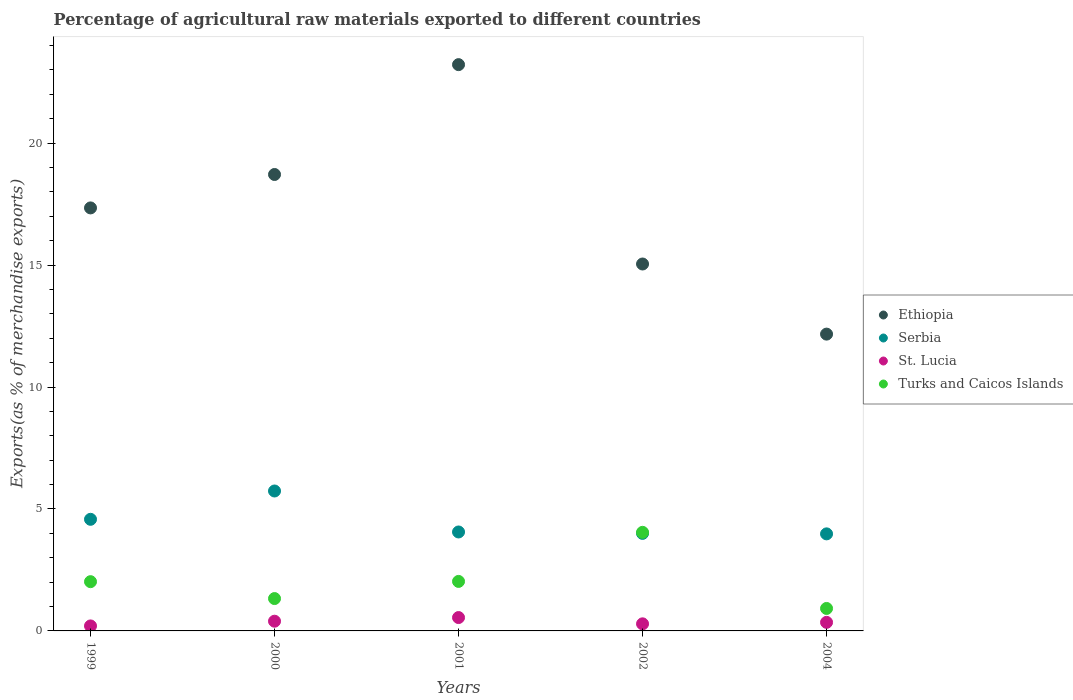Is the number of dotlines equal to the number of legend labels?
Your answer should be compact. Yes. What is the percentage of exports to different countries in Turks and Caicos Islands in 2002?
Provide a short and direct response. 4.04. Across all years, what is the maximum percentage of exports to different countries in St. Lucia?
Make the answer very short. 0.55. Across all years, what is the minimum percentage of exports to different countries in Turks and Caicos Islands?
Your answer should be compact. 0.92. In which year was the percentage of exports to different countries in Turks and Caicos Islands maximum?
Your answer should be very brief. 2002. What is the total percentage of exports to different countries in Serbia in the graph?
Your answer should be very brief. 22.35. What is the difference between the percentage of exports to different countries in St. Lucia in 2000 and that in 2002?
Offer a very short reply. 0.11. What is the difference between the percentage of exports to different countries in Turks and Caicos Islands in 2002 and the percentage of exports to different countries in Serbia in 1999?
Provide a short and direct response. -0.53. What is the average percentage of exports to different countries in Serbia per year?
Keep it short and to the point. 4.47. In the year 1999, what is the difference between the percentage of exports to different countries in Ethiopia and percentage of exports to different countries in Serbia?
Your answer should be compact. 12.77. What is the ratio of the percentage of exports to different countries in St. Lucia in 2001 to that in 2004?
Give a very brief answer. 1.56. Is the percentage of exports to different countries in Serbia in 2002 less than that in 2004?
Ensure brevity in your answer.  No. Is the difference between the percentage of exports to different countries in Ethiopia in 1999 and 2000 greater than the difference between the percentage of exports to different countries in Serbia in 1999 and 2000?
Your answer should be compact. No. What is the difference between the highest and the second highest percentage of exports to different countries in Turks and Caicos Islands?
Keep it short and to the point. 2.01. What is the difference between the highest and the lowest percentage of exports to different countries in Ethiopia?
Offer a very short reply. 11.05. Is the sum of the percentage of exports to different countries in Serbia in 2000 and 2002 greater than the maximum percentage of exports to different countries in Turks and Caicos Islands across all years?
Provide a short and direct response. Yes. Is it the case that in every year, the sum of the percentage of exports to different countries in Serbia and percentage of exports to different countries in Turks and Caicos Islands  is greater than the sum of percentage of exports to different countries in Ethiopia and percentage of exports to different countries in St. Lucia?
Keep it short and to the point. No. Is it the case that in every year, the sum of the percentage of exports to different countries in Serbia and percentage of exports to different countries in Ethiopia  is greater than the percentage of exports to different countries in Turks and Caicos Islands?
Ensure brevity in your answer.  Yes. Is the percentage of exports to different countries in Turks and Caicos Islands strictly greater than the percentage of exports to different countries in Ethiopia over the years?
Give a very brief answer. No. Is the percentage of exports to different countries in St. Lucia strictly less than the percentage of exports to different countries in Ethiopia over the years?
Your answer should be very brief. Yes. How many dotlines are there?
Ensure brevity in your answer.  4. How many years are there in the graph?
Give a very brief answer. 5. Are the values on the major ticks of Y-axis written in scientific E-notation?
Give a very brief answer. No. Does the graph contain grids?
Offer a very short reply. No. Where does the legend appear in the graph?
Give a very brief answer. Center right. How are the legend labels stacked?
Your answer should be compact. Vertical. What is the title of the graph?
Provide a succinct answer. Percentage of agricultural raw materials exported to different countries. Does "Dominican Republic" appear as one of the legend labels in the graph?
Your answer should be compact. No. What is the label or title of the Y-axis?
Your answer should be very brief. Exports(as % of merchandise exports). What is the Exports(as % of merchandise exports) in Ethiopia in 1999?
Keep it short and to the point. 17.34. What is the Exports(as % of merchandise exports) in Serbia in 1999?
Your answer should be very brief. 4.58. What is the Exports(as % of merchandise exports) of St. Lucia in 1999?
Make the answer very short. 0.2. What is the Exports(as % of merchandise exports) in Turks and Caicos Islands in 1999?
Your answer should be compact. 2.02. What is the Exports(as % of merchandise exports) of Ethiopia in 2000?
Your answer should be very brief. 18.71. What is the Exports(as % of merchandise exports) of Serbia in 2000?
Keep it short and to the point. 5.74. What is the Exports(as % of merchandise exports) in St. Lucia in 2000?
Your response must be concise. 0.4. What is the Exports(as % of merchandise exports) in Turks and Caicos Islands in 2000?
Provide a succinct answer. 1.33. What is the Exports(as % of merchandise exports) in Ethiopia in 2001?
Offer a very short reply. 23.22. What is the Exports(as % of merchandise exports) in Serbia in 2001?
Provide a short and direct response. 4.06. What is the Exports(as % of merchandise exports) of St. Lucia in 2001?
Your answer should be very brief. 0.55. What is the Exports(as % of merchandise exports) in Turks and Caicos Islands in 2001?
Make the answer very short. 2.03. What is the Exports(as % of merchandise exports) of Ethiopia in 2002?
Offer a terse response. 15.04. What is the Exports(as % of merchandise exports) of Serbia in 2002?
Give a very brief answer. 4. What is the Exports(as % of merchandise exports) of St. Lucia in 2002?
Give a very brief answer. 0.29. What is the Exports(as % of merchandise exports) of Turks and Caicos Islands in 2002?
Offer a terse response. 4.04. What is the Exports(as % of merchandise exports) in Ethiopia in 2004?
Give a very brief answer. 12.17. What is the Exports(as % of merchandise exports) in Serbia in 2004?
Your response must be concise. 3.98. What is the Exports(as % of merchandise exports) in St. Lucia in 2004?
Provide a succinct answer. 0.35. What is the Exports(as % of merchandise exports) in Turks and Caicos Islands in 2004?
Your response must be concise. 0.92. Across all years, what is the maximum Exports(as % of merchandise exports) in Ethiopia?
Keep it short and to the point. 23.22. Across all years, what is the maximum Exports(as % of merchandise exports) of Serbia?
Make the answer very short. 5.74. Across all years, what is the maximum Exports(as % of merchandise exports) of St. Lucia?
Provide a short and direct response. 0.55. Across all years, what is the maximum Exports(as % of merchandise exports) in Turks and Caicos Islands?
Ensure brevity in your answer.  4.04. Across all years, what is the minimum Exports(as % of merchandise exports) in Ethiopia?
Give a very brief answer. 12.17. Across all years, what is the minimum Exports(as % of merchandise exports) of Serbia?
Offer a very short reply. 3.98. Across all years, what is the minimum Exports(as % of merchandise exports) of St. Lucia?
Provide a short and direct response. 0.2. Across all years, what is the minimum Exports(as % of merchandise exports) of Turks and Caicos Islands?
Offer a very short reply. 0.92. What is the total Exports(as % of merchandise exports) in Ethiopia in the graph?
Provide a succinct answer. 86.49. What is the total Exports(as % of merchandise exports) in Serbia in the graph?
Your answer should be very brief. 22.35. What is the total Exports(as % of merchandise exports) of St. Lucia in the graph?
Your answer should be compact. 1.79. What is the total Exports(as % of merchandise exports) in Turks and Caicos Islands in the graph?
Offer a very short reply. 10.34. What is the difference between the Exports(as % of merchandise exports) in Ethiopia in 1999 and that in 2000?
Give a very brief answer. -1.37. What is the difference between the Exports(as % of merchandise exports) in Serbia in 1999 and that in 2000?
Offer a very short reply. -1.16. What is the difference between the Exports(as % of merchandise exports) of St. Lucia in 1999 and that in 2000?
Provide a succinct answer. -0.19. What is the difference between the Exports(as % of merchandise exports) in Turks and Caicos Islands in 1999 and that in 2000?
Ensure brevity in your answer.  0.69. What is the difference between the Exports(as % of merchandise exports) in Ethiopia in 1999 and that in 2001?
Ensure brevity in your answer.  -5.87. What is the difference between the Exports(as % of merchandise exports) in Serbia in 1999 and that in 2001?
Provide a succinct answer. 0.52. What is the difference between the Exports(as % of merchandise exports) in St. Lucia in 1999 and that in 2001?
Your response must be concise. -0.34. What is the difference between the Exports(as % of merchandise exports) of Turks and Caicos Islands in 1999 and that in 2001?
Provide a short and direct response. -0.01. What is the difference between the Exports(as % of merchandise exports) in Ethiopia in 1999 and that in 2002?
Your response must be concise. 2.3. What is the difference between the Exports(as % of merchandise exports) of Serbia in 1999 and that in 2002?
Keep it short and to the point. 0.58. What is the difference between the Exports(as % of merchandise exports) of St. Lucia in 1999 and that in 2002?
Ensure brevity in your answer.  -0.09. What is the difference between the Exports(as % of merchandise exports) in Turks and Caicos Islands in 1999 and that in 2002?
Make the answer very short. -2.02. What is the difference between the Exports(as % of merchandise exports) in Ethiopia in 1999 and that in 2004?
Keep it short and to the point. 5.17. What is the difference between the Exports(as % of merchandise exports) of Serbia in 1999 and that in 2004?
Give a very brief answer. 0.6. What is the difference between the Exports(as % of merchandise exports) of St. Lucia in 1999 and that in 2004?
Your response must be concise. -0.15. What is the difference between the Exports(as % of merchandise exports) in Turks and Caicos Islands in 1999 and that in 2004?
Provide a succinct answer. 1.1. What is the difference between the Exports(as % of merchandise exports) of Ethiopia in 2000 and that in 2001?
Provide a succinct answer. -4.5. What is the difference between the Exports(as % of merchandise exports) in Serbia in 2000 and that in 2001?
Give a very brief answer. 1.68. What is the difference between the Exports(as % of merchandise exports) of St. Lucia in 2000 and that in 2001?
Provide a succinct answer. -0.15. What is the difference between the Exports(as % of merchandise exports) in Turks and Caicos Islands in 2000 and that in 2001?
Offer a very short reply. -0.7. What is the difference between the Exports(as % of merchandise exports) in Ethiopia in 2000 and that in 2002?
Your answer should be compact. 3.67. What is the difference between the Exports(as % of merchandise exports) of Serbia in 2000 and that in 2002?
Offer a very short reply. 1.74. What is the difference between the Exports(as % of merchandise exports) of St. Lucia in 2000 and that in 2002?
Make the answer very short. 0.11. What is the difference between the Exports(as % of merchandise exports) in Turks and Caicos Islands in 2000 and that in 2002?
Offer a very short reply. -2.72. What is the difference between the Exports(as % of merchandise exports) in Ethiopia in 2000 and that in 2004?
Make the answer very short. 6.55. What is the difference between the Exports(as % of merchandise exports) of Serbia in 2000 and that in 2004?
Provide a short and direct response. 1.76. What is the difference between the Exports(as % of merchandise exports) of St. Lucia in 2000 and that in 2004?
Make the answer very short. 0.05. What is the difference between the Exports(as % of merchandise exports) of Turks and Caicos Islands in 2000 and that in 2004?
Make the answer very short. 0.41. What is the difference between the Exports(as % of merchandise exports) of Ethiopia in 2001 and that in 2002?
Your answer should be compact. 8.17. What is the difference between the Exports(as % of merchandise exports) of Serbia in 2001 and that in 2002?
Offer a terse response. 0.06. What is the difference between the Exports(as % of merchandise exports) of St. Lucia in 2001 and that in 2002?
Provide a short and direct response. 0.26. What is the difference between the Exports(as % of merchandise exports) in Turks and Caicos Islands in 2001 and that in 2002?
Make the answer very short. -2.01. What is the difference between the Exports(as % of merchandise exports) of Ethiopia in 2001 and that in 2004?
Offer a terse response. 11.05. What is the difference between the Exports(as % of merchandise exports) of Serbia in 2001 and that in 2004?
Ensure brevity in your answer.  0.08. What is the difference between the Exports(as % of merchandise exports) of St. Lucia in 2001 and that in 2004?
Make the answer very short. 0.2. What is the difference between the Exports(as % of merchandise exports) in Turks and Caicos Islands in 2001 and that in 2004?
Your answer should be compact. 1.11. What is the difference between the Exports(as % of merchandise exports) of Ethiopia in 2002 and that in 2004?
Offer a terse response. 2.88. What is the difference between the Exports(as % of merchandise exports) of Serbia in 2002 and that in 2004?
Your response must be concise. 0.02. What is the difference between the Exports(as % of merchandise exports) of St. Lucia in 2002 and that in 2004?
Provide a succinct answer. -0.06. What is the difference between the Exports(as % of merchandise exports) in Turks and Caicos Islands in 2002 and that in 2004?
Make the answer very short. 3.12. What is the difference between the Exports(as % of merchandise exports) in Ethiopia in 1999 and the Exports(as % of merchandise exports) in Serbia in 2000?
Provide a succinct answer. 11.61. What is the difference between the Exports(as % of merchandise exports) in Ethiopia in 1999 and the Exports(as % of merchandise exports) in St. Lucia in 2000?
Make the answer very short. 16.95. What is the difference between the Exports(as % of merchandise exports) of Ethiopia in 1999 and the Exports(as % of merchandise exports) of Turks and Caicos Islands in 2000?
Your answer should be very brief. 16.02. What is the difference between the Exports(as % of merchandise exports) in Serbia in 1999 and the Exports(as % of merchandise exports) in St. Lucia in 2000?
Keep it short and to the point. 4.18. What is the difference between the Exports(as % of merchandise exports) in Serbia in 1999 and the Exports(as % of merchandise exports) in Turks and Caicos Islands in 2000?
Make the answer very short. 3.25. What is the difference between the Exports(as % of merchandise exports) in St. Lucia in 1999 and the Exports(as % of merchandise exports) in Turks and Caicos Islands in 2000?
Your answer should be compact. -1.12. What is the difference between the Exports(as % of merchandise exports) in Ethiopia in 1999 and the Exports(as % of merchandise exports) in Serbia in 2001?
Give a very brief answer. 13.29. What is the difference between the Exports(as % of merchandise exports) of Ethiopia in 1999 and the Exports(as % of merchandise exports) of St. Lucia in 2001?
Make the answer very short. 16.8. What is the difference between the Exports(as % of merchandise exports) in Ethiopia in 1999 and the Exports(as % of merchandise exports) in Turks and Caicos Islands in 2001?
Offer a terse response. 15.31. What is the difference between the Exports(as % of merchandise exports) in Serbia in 1999 and the Exports(as % of merchandise exports) in St. Lucia in 2001?
Your answer should be compact. 4.03. What is the difference between the Exports(as % of merchandise exports) in Serbia in 1999 and the Exports(as % of merchandise exports) in Turks and Caicos Islands in 2001?
Provide a succinct answer. 2.55. What is the difference between the Exports(as % of merchandise exports) in St. Lucia in 1999 and the Exports(as % of merchandise exports) in Turks and Caicos Islands in 2001?
Keep it short and to the point. -1.83. What is the difference between the Exports(as % of merchandise exports) of Ethiopia in 1999 and the Exports(as % of merchandise exports) of Serbia in 2002?
Offer a terse response. 13.34. What is the difference between the Exports(as % of merchandise exports) of Ethiopia in 1999 and the Exports(as % of merchandise exports) of St. Lucia in 2002?
Offer a very short reply. 17.05. What is the difference between the Exports(as % of merchandise exports) in Ethiopia in 1999 and the Exports(as % of merchandise exports) in Turks and Caicos Islands in 2002?
Your answer should be compact. 13.3. What is the difference between the Exports(as % of merchandise exports) in Serbia in 1999 and the Exports(as % of merchandise exports) in St. Lucia in 2002?
Give a very brief answer. 4.29. What is the difference between the Exports(as % of merchandise exports) of Serbia in 1999 and the Exports(as % of merchandise exports) of Turks and Caicos Islands in 2002?
Ensure brevity in your answer.  0.53. What is the difference between the Exports(as % of merchandise exports) of St. Lucia in 1999 and the Exports(as % of merchandise exports) of Turks and Caicos Islands in 2002?
Offer a very short reply. -3.84. What is the difference between the Exports(as % of merchandise exports) in Ethiopia in 1999 and the Exports(as % of merchandise exports) in Serbia in 2004?
Make the answer very short. 13.37. What is the difference between the Exports(as % of merchandise exports) of Ethiopia in 1999 and the Exports(as % of merchandise exports) of St. Lucia in 2004?
Keep it short and to the point. 16.99. What is the difference between the Exports(as % of merchandise exports) of Ethiopia in 1999 and the Exports(as % of merchandise exports) of Turks and Caicos Islands in 2004?
Provide a short and direct response. 16.42. What is the difference between the Exports(as % of merchandise exports) of Serbia in 1999 and the Exports(as % of merchandise exports) of St. Lucia in 2004?
Offer a very short reply. 4.23. What is the difference between the Exports(as % of merchandise exports) in Serbia in 1999 and the Exports(as % of merchandise exports) in Turks and Caicos Islands in 2004?
Provide a short and direct response. 3.66. What is the difference between the Exports(as % of merchandise exports) in St. Lucia in 1999 and the Exports(as % of merchandise exports) in Turks and Caicos Islands in 2004?
Keep it short and to the point. -0.72. What is the difference between the Exports(as % of merchandise exports) of Ethiopia in 2000 and the Exports(as % of merchandise exports) of Serbia in 2001?
Your answer should be compact. 14.66. What is the difference between the Exports(as % of merchandise exports) of Ethiopia in 2000 and the Exports(as % of merchandise exports) of St. Lucia in 2001?
Ensure brevity in your answer.  18.17. What is the difference between the Exports(as % of merchandise exports) in Ethiopia in 2000 and the Exports(as % of merchandise exports) in Turks and Caicos Islands in 2001?
Your response must be concise. 16.68. What is the difference between the Exports(as % of merchandise exports) of Serbia in 2000 and the Exports(as % of merchandise exports) of St. Lucia in 2001?
Your response must be concise. 5.19. What is the difference between the Exports(as % of merchandise exports) of Serbia in 2000 and the Exports(as % of merchandise exports) of Turks and Caicos Islands in 2001?
Give a very brief answer. 3.71. What is the difference between the Exports(as % of merchandise exports) in St. Lucia in 2000 and the Exports(as % of merchandise exports) in Turks and Caicos Islands in 2001?
Offer a very short reply. -1.63. What is the difference between the Exports(as % of merchandise exports) of Ethiopia in 2000 and the Exports(as % of merchandise exports) of Serbia in 2002?
Provide a short and direct response. 14.71. What is the difference between the Exports(as % of merchandise exports) of Ethiopia in 2000 and the Exports(as % of merchandise exports) of St. Lucia in 2002?
Make the answer very short. 18.42. What is the difference between the Exports(as % of merchandise exports) of Ethiopia in 2000 and the Exports(as % of merchandise exports) of Turks and Caicos Islands in 2002?
Provide a succinct answer. 14.67. What is the difference between the Exports(as % of merchandise exports) in Serbia in 2000 and the Exports(as % of merchandise exports) in St. Lucia in 2002?
Your response must be concise. 5.45. What is the difference between the Exports(as % of merchandise exports) of Serbia in 2000 and the Exports(as % of merchandise exports) of Turks and Caicos Islands in 2002?
Keep it short and to the point. 1.7. What is the difference between the Exports(as % of merchandise exports) of St. Lucia in 2000 and the Exports(as % of merchandise exports) of Turks and Caicos Islands in 2002?
Make the answer very short. -3.64. What is the difference between the Exports(as % of merchandise exports) of Ethiopia in 2000 and the Exports(as % of merchandise exports) of Serbia in 2004?
Provide a short and direct response. 14.74. What is the difference between the Exports(as % of merchandise exports) of Ethiopia in 2000 and the Exports(as % of merchandise exports) of St. Lucia in 2004?
Ensure brevity in your answer.  18.36. What is the difference between the Exports(as % of merchandise exports) in Ethiopia in 2000 and the Exports(as % of merchandise exports) in Turks and Caicos Islands in 2004?
Offer a very short reply. 17.79. What is the difference between the Exports(as % of merchandise exports) of Serbia in 2000 and the Exports(as % of merchandise exports) of St. Lucia in 2004?
Offer a terse response. 5.39. What is the difference between the Exports(as % of merchandise exports) of Serbia in 2000 and the Exports(as % of merchandise exports) of Turks and Caicos Islands in 2004?
Provide a short and direct response. 4.82. What is the difference between the Exports(as % of merchandise exports) of St. Lucia in 2000 and the Exports(as % of merchandise exports) of Turks and Caicos Islands in 2004?
Provide a short and direct response. -0.52. What is the difference between the Exports(as % of merchandise exports) of Ethiopia in 2001 and the Exports(as % of merchandise exports) of Serbia in 2002?
Your answer should be compact. 19.22. What is the difference between the Exports(as % of merchandise exports) of Ethiopia in 2001 and the Exports(as % of merchandise exports) of St. Lucia in 2002?
Offer a very short reply. 22.93. What is the difference between the Exports(as % of merchandise exports) of Ethiopia in 2001 and the Exports(as % of merchandise exports) of Turks and Caicos Islands in 2002?
Ensure brevity in your answer.  19.18. What is the difference between the Exports(as % of merchandise exports) of Serbia in 2001 and the Exports(as % of merchandise exports) of St. Lucia in 2002?
Offer a very short reply. 3.77. What is the difference between the Exports(as % of merchandise exports) in Serbia in 2001 and the Exports(as % of merchandise exports) in Turks and Caicos Islands in 2002?
Keep it short and to the point. 0.02. What is the difference between the Exports(as % of merchandise exports) of St. Lucia in 2001 and the Exports(as % of merchandise exports) of Turks and Caicos Islands in 2002?
Make the answer very short. -3.49. What is the difference between the Exports(as % of merchandise exports) in Ethiopia in 2001 and the Exports(as % of merchandise exports) in Serbia in 2004?
Provide a succinct answer. 19.24. What is the difference between the Exports(as % of merchandise exports) in Ethiopia in 2001 and the Exports(as % of merchandise exports) in St. Lucia in 2004?
Ensure brevity in your answer.  22.87. What is the difference between the Exports(as % of merchandise exports) of Ethiopia in 2001 and the Exports(as % of merchandise exports) of Turks and Caicos Islands in 2004?
Ensure brevity in your answer.  22.3. What is the difference between the Exports(as % of merchandise exports) of Serbia in 2001 and the Exports(as % of merchandise exports) of St. Lucia in 2004?
Keep it short and to the point. 3.71. What is the difference between the Exports(as % of merchandise exports) of Serbia in 2001 and the Exports(as % of merchandise exports) of Turks and Caicos Islands in 2004?
Keep it short and to the point. 3.14. What is the difference between the Exports(as % of merchandise exports) in St. Lucia in 2001 and the Exports(as % of merchandise exports) in Turks and Caicos Islands in 2004?
Your answer should be compact. -0.37. What is the difference between the Exports(as % of merchandise exports) in Ethiopia in 2002 and the Exports(as % of merchandise exports) in Serbia in 2004?
Make the answer very short. 11.07. What is the difference between the Exports(as % of merchandise exports) in Ethiopia in 2002 and the Exports(as % of merchandise exports) in St. Lucia in 2004?
Keep it short and to the point. 14.69. What is the difference between the Exports(as % of merchandise exports) in Ethiopia in 2002 and the Exports(as % of merchandise exports) in Turks and Caicos Islands in 2004?
Ensure brevity in your answer.  14.12. What is the difference between the Exports(as % of merchandise exports) of Serbia in 2002 and the Exports(as % of merchandise exports) of St. Lucia in 2004?
Provide a short and direct response. 3.65. What is the difference between the Exports(as % of merchandise exports) in Serbia in 2002 and the Exports(as % of merchandise exports) in Turks and Caicos Islands in 2004?
Give a very brief answer. 3.08. What is the difference between the Exports(as % of merchandise exports) of St. Lucia in 2002 and the Exports(as % of merchandise exports) of Turks and Caicos Islands in 2004?
Provide a succinct answer. -0.63. What is the average Exports(as % of merchandise exports) in Ethiopia per year?
Your response must be concise. 17.3. What is the average Exports(as % of merchandise exports) of Serbia per year?
Give a very brief answer. 4.47. What is the average Exports(as % of merchandise exports) of St. Lucia per year?
Provide a succinct answer. 0.36. What is the average Exports(as % of merchandise exports) of Turks and Caicos Islands per year?
Make the answer very short. 2.07. In the year 1999, what is the difference between the Exports(as % of merchandise exports) in Ethiopia and Exports(as % of merchandise exports) in Serbia?
Give a very brief answer. 12.77. In the year 1999, what is the difference between the Exports(as % of merchandise exports) of Ethiopia and Exports(as % of merchandise exports) of St. Lucia?
Offer a very short reply. 17.14. In the year 1999, what is the difference between the Exports(as % of merchandise exports) of Ethiopia and Exports(as % of merchandise exports) of Turks and Caicos Islands?
Your answer should be compact. 15.33. In the year 1999, what is the difference between the Exports(as % of merchandise exports) in Serbia and Exports(as % of merchandise exports) in St. Lucia?
Offer a very short reply. 4.37. In the year 1999, what is the difference between the Exports(as % of merchandise exports) in Serbia and Exports(as % of merchandise exports) in Turks and Caicos Islands?
Provide a succinct answer. 2.56. In the year 1999, what is the difference between the Exports(as % of merchandise exports) in St. Lucia and Exports(as % of merchandise exports) in Turks and Caicos Islands?
Your response must be concise. -1.81. In the year 2000, what is the difference between the Exports(as % of merchandise exports) of Ethiopia and Exports(as % of merchandise exports) of Serbia?
Provide a short and direct response. 12.98. In the year 2000, what is the difference between the Exports(as % of merchandise exports) in Ethiopia and Exports(as % of merchandise exports) in St. Lucia?
Ensure brevity in your answer.  18.32. In the year 2000, what is the difference between the Exports(as % of merchandise exports) in Ethiopia and Exports(as % of merchandise exports) in Turks and Caicos Islands?
Make the answer very short. 17.39. In the year 2000, what is the difference between the Exports(as % of merchandise exports) in Serbia and Exports(as % of merchandise exports) in St. Lucia?
Ensure brevity in your answer.  5.34. In the year 2000, what is the difference between the Exports(as % of merchandise exports) in Serbia and Exports(as % of merchandise exports) in Turks and Caicos Islands?
Ensure brevity in your answer.  4.41. In the year 2000, what is the difference between the Exports(as % of merchandise exports) of St. Lucia and Exports(as % of merchandise exports) of Turks and Caicos Islands?
Your response must be concise. -0.93. In the year 2001, what is the difference between the Exports(as % of merchandise exports) in Ethiopia and Exports(as % of merchandise exports) in Serbia?
Offer a very short reply. 19.16. In the year 2001, what is the difference between the Exports(as % of merchandise exports) of Ethiopia and Exports(as % of merchandise exports) of St. Lucia?
Offer a very short reply. 22.67. In the year 2001, what is the difference between the Exports(as % of merchandise exports) in Ethiopia and Exports(as % of merchandise exports) in Turks and Caicos Islands?
Your response must be concise. 21.19. In the year 2001, what is the difference between the Exports(as % of merchandise exports) in Serbia and Exports(as % of merchandise exports) in St. Lucia?
Your answer should be very brief. 3.51. In the year 2001, what is the difference between the Exports(as % of merchandise exports) in Serbia and Exports(as % of merchandise exports) in Turks and Caicos Islands?
Make the answer very short. 2.03. In the year 2001, what is the difference between the Exports(as % of merchandise exports) in St. Lucia and Exports(as % of merchandise exports) in Turks and Caicos Islands?
Offer a terse response. -1.48. In the year 2002, what is the difference between the Exports(as % of merchandise exports) of Ethiopia and Exports(as % of merchandise exports) of Serbia?
Make the answer very short. 11.04. In the year 2002, what is the difference between the Exports(as % of merchandise exports) in Ethiopia and Exports(as % of merchandise exports) in St. Lucia?
Give a very brief answer. 14.75. In the year 2002, what is the difference between the Exports(as % of merchandise exports) in Ethiopia and Exports(as % of merchandise exports) in Turks and Caicos Islands?
Give a very brief answer. 11. In the year 2002, what is the difference between the Exports(as % of merchandise exports) of Serbia and Exports(as % of merchandise exports) of St. Lucia?
Offer a terse response. 3.71. In the year 2002, what is the difference between the Exports(as % of merchandise exports) in Serbia and Exports(as % of merchandise exports) in Turks and Caicos Islands?
Offer a terse response. -0.04. In the year 2002, what is the difference between the Exports(as % of merchandise exports) in St. Lucia and Exports(as % of merchandise exports) in Turks and Caicos Islands?
Ensure brevity in your answer.  -3.75. In the year 2004, what is the difference between the Exports(as % of merchandise exports) of Ethiopia and Exports(as % of merchandise exports) of Serbia?
Your response must be concise. 8.19. In the year 2004, what is the difference between the Exports(as % of merchandise exports) of Ethiopia and Exports(as % of merchandise exports) of St. Lucia?
Give a very brief answer. 11.82. In the year 2004, what is the difference between the Exports(as % of merchandise exports) in Ethiopia and Exports(as % of merchandise exports) in Turks and Caicos Islands?
Provide a succinct answer. 11.25. In the year 2004, what is the difference between the Exports(as % of merchandise exports) of Serbia and Exports(as % of merchandise exports) of St. Lucia?
Keep it short and to the point. 3.63. In the year 2004, what is the difference between the Exports(as % of merchandise exports) of Serbia and Exports(as % of merchandise exports) of Turks and Caicos Islands?
Keep it short and to the point. 3.06. In the year 2004, what is the difference between the Exports(as % of merchandise exports) in St. Lucia and Exports(as % of merchandise exports) in Turks and Caicos Islands?
Your answer should be compact. -0.57. What is the ratio of the Exports(as % of merchandise exports) of Ethiopia in 1999 to that in 2000?
Keep it short and to the point. 0.93. What is the ratio of the Exports(as % of merchandise exports) of Serbia in 1999 to that in 2000?
Keep it short and to the point. 0.8. What is the ratio of the Exports(as % of merchandise exports) of St. Lucia in 1999 to that in 2000?
Make the answer very short. 0.51. What is the ratio of the Exports(as % of merchandise exports) in Turks and Caicos Islands in 1999 to that in 2000?
Your response must be concise. 1.52. What is the ratio of the Exports(as % of merchandise exports) in Ethiopia in 1999 to that in 2001?
Provide a short and direct response. 0.75. What is the ratio of the Exports(as % of merchandise exports) in Serbia in 1999 to that in 2001?
Ensure brevity in your answer.  1.13. What is the ratio of the Exports(as % of merchandise exports) in St. Lucia in 1999 to that in 2001?
Your answer should be very brief. 0.37. What is the ratio of the Exports(as % of merchandise exports) of Turks and Caicos Islands in 1999 to that in 2001?
Offer a terse response. 0.99. What is the ratio of the Exports(as % of merchandise exports) in Ethiopia in 1999 to that in 2002?
Ensure brevity in your answer.  1.15. What is the ratio of the Exports(as % of merchandise exports) in Serbia in 1999 to that in 2002?
Offer a very short reply. 1.14. What is the ratio of the Exports(as % of merchandise exports) of St. Lucia in 1999 to that in 2002?
Provide a short and direct response. 0.7. What is the ratio of the Exports(as % of merchandise exports) of Turks and Caicos Islands in 1999 to that in 2002?
Your answer should be very brief. 0.5. What is the ratio of the Exports(as % of merchandise exports) in Ethiopia in 1999 to that in 2004?
Give a very brief answer. 1.43. What is the ratio of the Exports(as % of merchandise exports) of Serbia in 1999 to that in 2004?
Your answer should be very brief. 1.15. What is the ratio of the Exports(as % of merchandise exports) of St. Lucia in 1999 to that in 2004?
Keep it short and to the point. 0.58. What is the ratio of the Exports(as % of merchandise exports) in Turks and Caicos Islands in 1999 to that in 2004?
Make the answer very short. 2.19. What is the ratio of the Exports(as % of merchandise exports) in Ethiopia in 2000 to that in 2001?
Make the answer very short. 0.81. What is the ratio of the Exports(as % of merchandise exports) in Serbia in 2000 to that in 2001?
Make the answer very short. 1.41. What is the ratio of the Exports(as % of merchandise exports) in St. Lucia in 2000 to that in 2001?
Make the answer very short. 0.73. What is the ratio of the Exports(as % of merchandise exports) in Turks and Caicos Islands in 2000 to that in 2001?
Ensure brevity in your answer.  0.65. What is the ratio of the Exports(as % of merchandise exports) in Ethiopia in 2000 to that in 2002?
Give a very brief answer. 1.24. What is the ratio of the Exports(as % of merchandise exports) in Serbia in 2000 to that in 2002?
Provide a short and direct response. 1.43. What is the ratio of the Exports(as % of merchandise exports) of St. Lucia in 2000 to that in 2002?
Offer a terse response. 1.37. What is the ratio of the Exports(as % of merchandise exports) of Turks and Caicos Islands in 2000 to that in 2002?
Make the answer very short. 0.33. What is the ratio of the Exports(as % of merchandise exports) of Ethiopia in 2000 to that in 2004?
Your response must be concise. 1.54. What is the ratio of the Exports(as % of merchandise exports) of Serbia in 2000 to that in 2004?
Your response must be concise. 1.44. What is the ratio of the Exports(as % of merchandise exports) of St. Lucia in 2000 to that in 2004?
Provide a succinct answer. 1.13. What is the ratio of the Exports(as % of merchandise exports) in Turks and Caicos Islands in 2000 to that in 2004?
Offer a very short reply. 1.44. What is the ratio of the Exports(as % of merchandise exports) of Ethiopia in 2001 to that in 2002?
Ensure brevity in your answer.  1.54. What is the ratio of the Exports(as % of merchandise exports) of Serbia in 2001 to that in 2002?
Give a very brief answer. 1.01. What is the ratio of the Exports(as % of merchandise exports) of St. Lucia in 2001 to that in 2002?
Make the answer very short. 1.88. What is the ratio of the Exports(as % of merchandise exports) of Turks and Caicos Islands in 2001 to that in 2002?
Offer a terse response. 0.5. What is the ratio of the Exports(as % of merchandise exports) in Ethiopia in 2001 to that in 2004?
Provide a short and direct response. 1.91. What is the ratio of the Exports(as % of merchandise exports) of Serbia in 2001 to that in 2004?
Provide a short and direct response. 1.02. What is the ratio of the Exports(as % of merchandise exports) in St. Lucia in 2001 to that in 2004?
Give a very brief answer. 1.56. What is the ratio of the Exports(as % of merchandise exports) of Turks and Caicos Islands in 2001 to that in 2004?
Provide a succinct answer. 2.2. What is the ratio of the Exports(as % of merchandise exports) of Ethiopia in 2002 to that in 2004?
Offer a terse response. 1.24. What is the ratio of the Exports(as % of merchandise exports) in Serbia in 2002 to that in 2004?
Your answer should be very brief. 1.01. What is the ratio of the Exports(as % of merchandise exports) in St. Lucia in 2002 to that in 2004?
Give a very brief answer. 0.83. What is the ratio of the Exports(as % of merchandise exports) of Turks and Caicos Islands in 2002 to that in 2004?
Offer a terse response. 4.39. What is the difference between the highest and the second highest Exports(as % of merchandise exports) of Ethiopia?
Your response must be concise. 4.5. What is the difference between the highest and the second highest Exports(as % of merchandise exports) of Serbia?
Your answer should be compact. 1.16. What is the difference between the highest and the second highest Exports(as % of merchandise exports) of St. Lucia?
Provide a short and direct response. 0.15. What is the difference between the highest and the second highest Exports(as % of merchandise exports) in Turks and Caicos Islands?
Provide a short and direct response. 2.01. What is the difference between the highest and the lowest Exports(as % of merchandise exports) in Ethiopia?
Provide a short and direct response. 11.05. What is the difference between the highest and the lowest Exports(as % of merchandise exports) of Serbia?
Make the answer very short. 1.76. What is the difference between the highest and the lowest Exports(as % of merchandise exports) in St. Lucia?
Ensure brevity in your answer.  0.34. What is the difference between the highest and the lowest Exports(as % of merchandise exports) in Turks and Caicos Islands?
Your answer should be very brief. 3.12. 